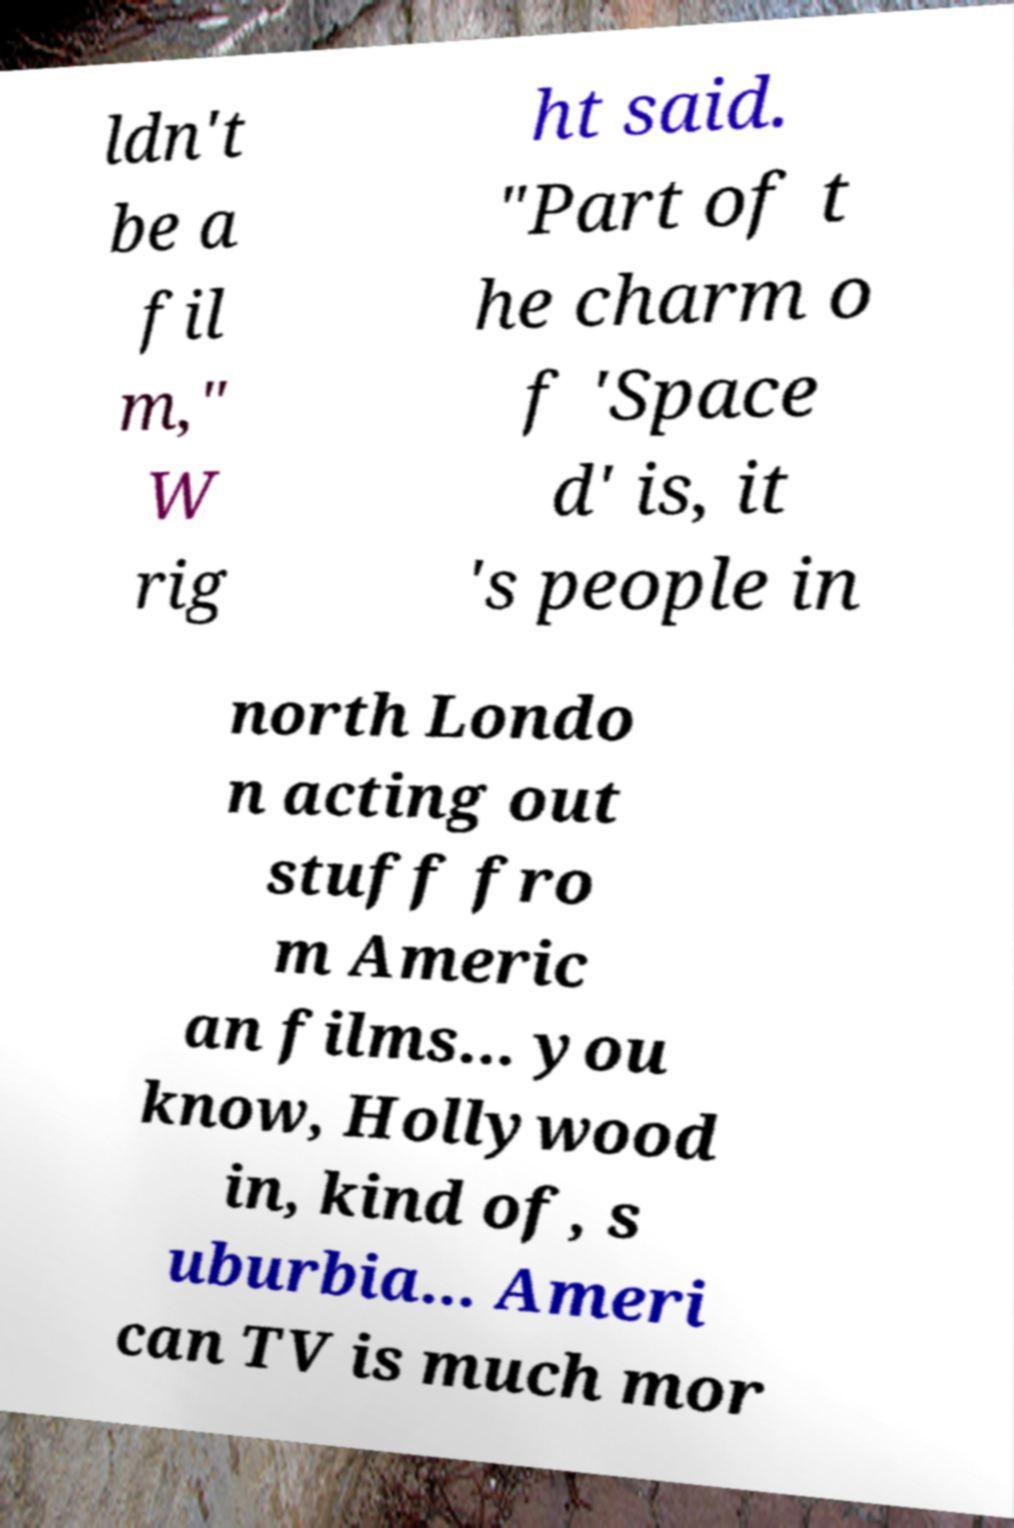Could you extract and type out the text from this image? ldn't be a fil m," W rig ht said. "Part of t he charm o f 'Space d' is, it 's people in north Londo n acting out stuff fro m Americ an films... you know, Hollywood in, kind of, s uburbia... Ameri can TV is much mor 